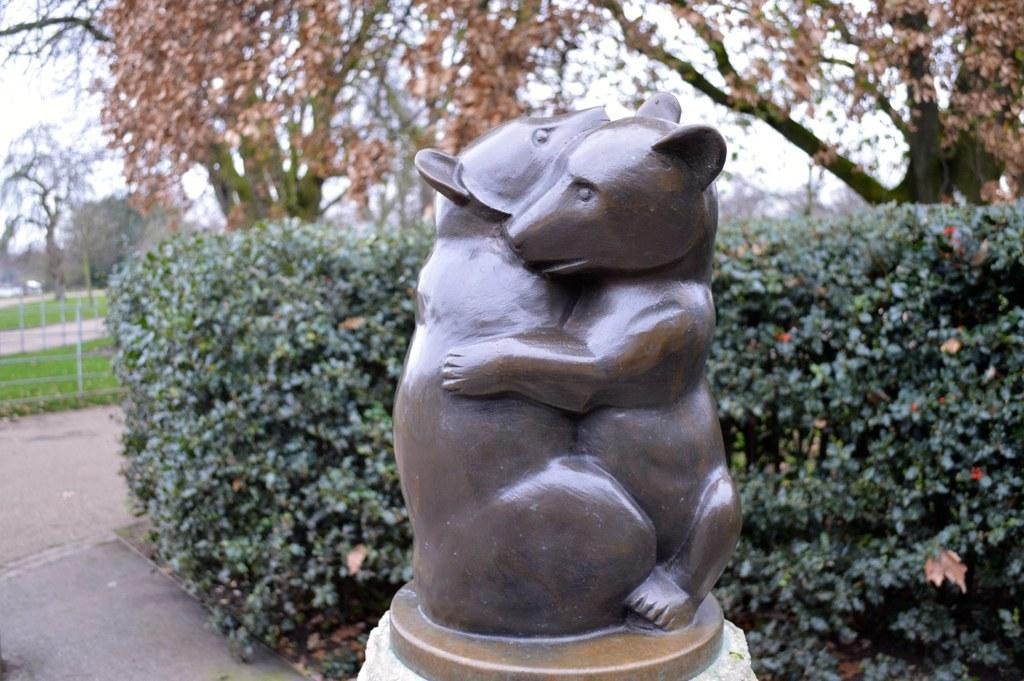What is the main subject of the image? There is a statue of two animals hugging in the image. What can be seen in the background of the image? There are shrubs, grass, a fence, trees, and the sky visible in the background of the image. What is the purpose of the arch in the image? There is no arch present in the image. 